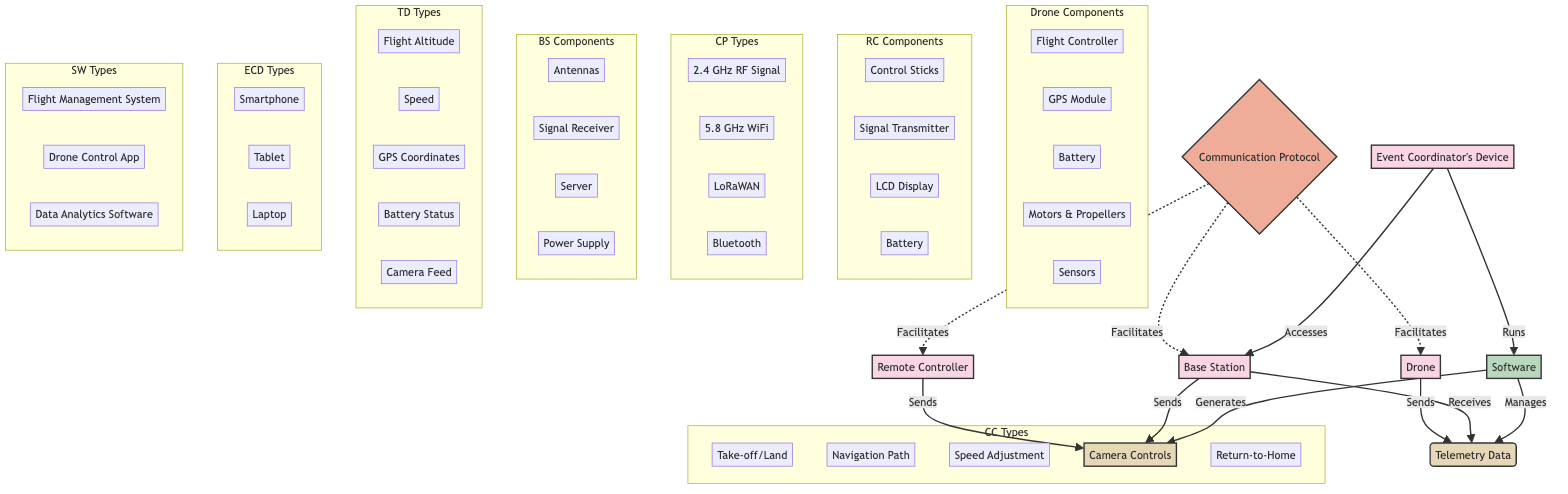What are the main components of the Drone? The diagram lists components within a subgraph labeled "Drone Components," which includes the Flight Controller, GPS Module, Battery, Motors & Propellers, and Sensors.
Answer: Flight Controller, GPS Module, Battery, Motors & Propellers, Sensors How many different communication protocols are represented? The diagram includes a subgraph labeled "CP Types" showing four communication protocols: 2.4 GHz RF Signal, 5.8 GHz WiFi, LoRaWAN, and Bluetooth. Counting these, we see there are four distinct protocols.
Answer: Four What data does the Telemetry Data include? The subgraph labeled "TD Types" highlights the specific types of data included in Telemetry Data: Flight Altitude, Speed, GPS Coordinates, Battery Status, and Camera Feed.
Answer: Flight Altitude, Speed, GPS Coordinates, Battery Status, Camera Feed Which component facilitates communication between the Drone and the Base Station? The diagram depicts the Communication Protocol as a solid line with a dashed connection that indicates it facilitates communication between the Drone and the Base Station, establishing their relationship.
Answer: Communication Protocol How does the Event Coordinator's Device interact with the Base Station? The diagram shows a directed connection from the Event Coordinator's Device to the Base Station indicating that it accesses the Base Station. Additionally, it shows that the Event Coordinator's Device runs Software, which manages and generates related commands and data.
Answer: Accesses What types of control commands are shown in the diagram? In the subgraph labeled "CC Types," there are five outlined control commands: Take-off/Land, Navigation Path, Speed Adjustment, Camera Controls, and Return-to-Home, which points to a structured control command system for the drone.
Answer: Take-off/Land, Navigation Path, Speed Adjustment, Camera Controls, Return-to-Home Which entity manages the Telemetry Data? The diagram depicts a directed edge from Software to Telemetry Data, indicating that the Software manages the collection and processing of the telemetry data being sent and received.
Answer: Software What is the role of the Base Station in this network diagram? The Base Station is depicted as both a receiver of Telemetry Data from the Drone and a sender of Control Commands back to the Drone, showing that it plays a crucial intermediary role in communication.
Answer: Receiver and Sender How does the Remote Controller obtain command inputs for the drone? The diagram illustrates that the Remote Controller sends Control Commands through a directed edge, indicating it's responsible for generating user inputs to control the drone’s operations.
Answer: Sends 